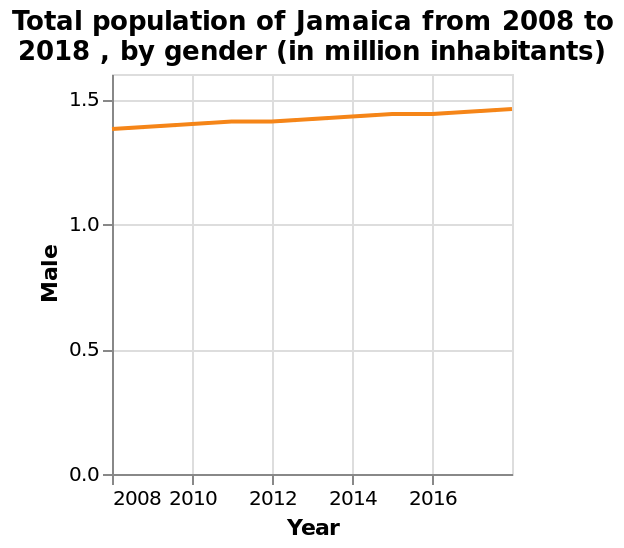<image>
What was the male population of Jamaica in 2008?  The description does not provide information about the male population of Jamaica in 2008. Which year had the highest male population in Jamaica? The description does not provide information about the year with the highest male population in Jamaica. 